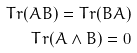Convert formula to latex. <formula><loc_0><loc_0><loc_500><loc_500>T r ( A B ) = T r ( B A ) \\ T r ( A \wedge B ) = 0</formula> 